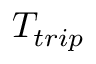<formula> <loc_0><loc_0><loc_500><loc_500>T _ { t r i p }</formula> 